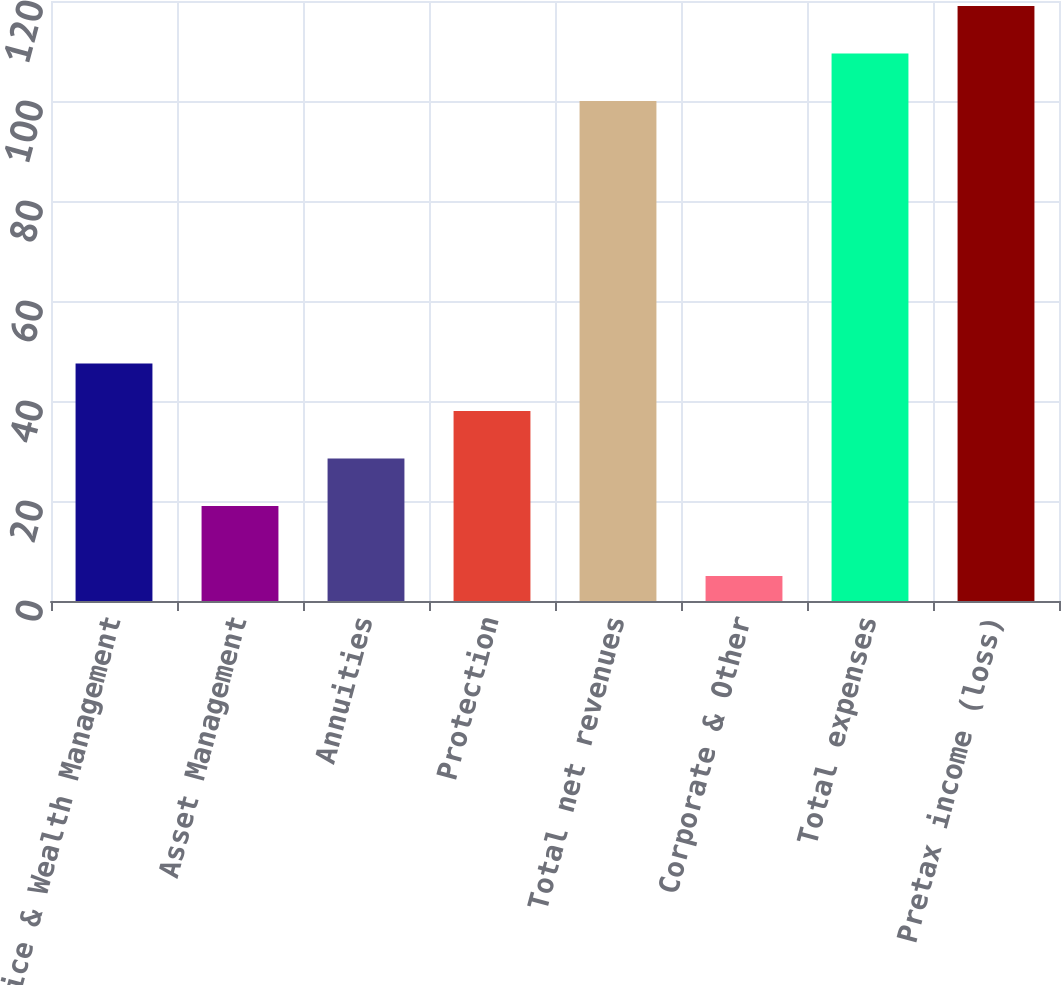Convert chart. <chart><loc_0><loc_0><loc_500><loc_500><bar_chart><fcel>Advice & Wealth Management<fcel>Asset Management<fcel>Annuities<fcel>Protection<fcel>Total net revenues<fcel>Corporate & Other<fcel>Total expenses<fcel>Pretax income (loss)<nl><fcel>47.5<fcel>19<fcel>28.5<fcel>38<fcel>100<fcel>5<fcel>109.5<fcel>119<nl></chart> 